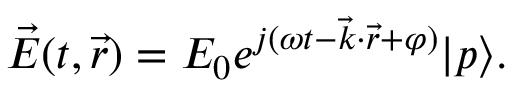<formula> <loc_0><loc_0><loc_500><loc_500>\vec { E } ( t , \vec { r } ) = E _ { 0 } e ^ { j ( \omega t - \vec { k } \cdot \vec { r } + \varphi ) } | p \rangle .</formula> 